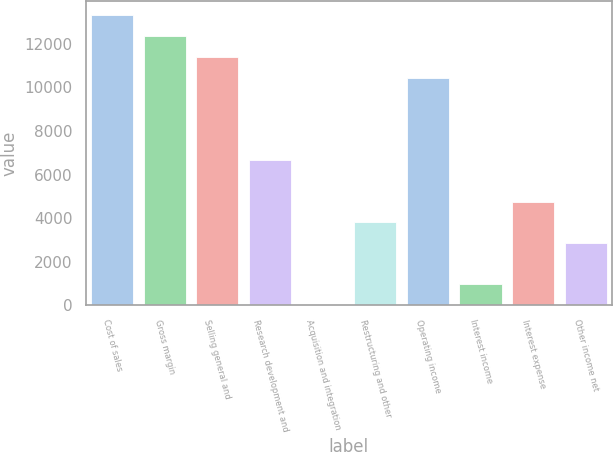Convert chart to OTSL. <chart><loc_0><loc_0><loc_500><loc_500><bar_chart><fcel>Cost of sales<fcel>Gross margin<fcel>Selling general and<fcel>Research development and<fcel>Acquisition and integration<fcel>Restructuring and other<fcel>Operating income<fcel>Interest income<fcel>Interest expense<fcel>Other income net<nl><fcel>13302.2<fcel>12353.4<fcel>11404.6<fcel>6660.6<fcel>19<fcel>3814.2<fcel>10455.8<fcel>967.8<fcel>4763<fcel>2865.4<nl></chart> 